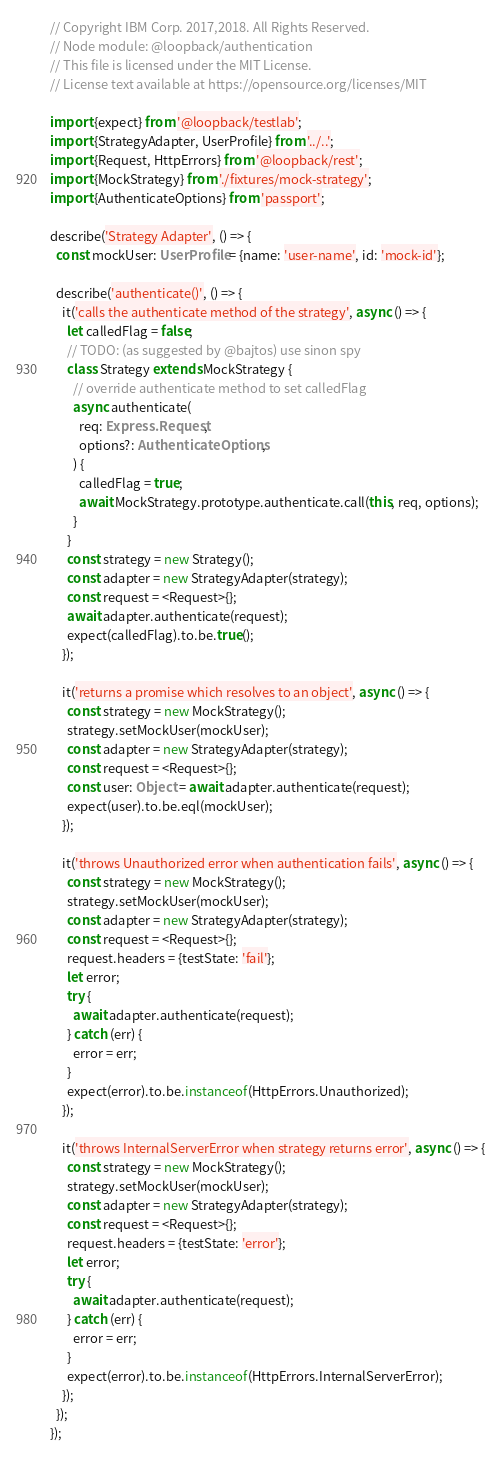<code> <loc_0><loc_0><loc_500><loc_500><_TypeScript_>// Copyright IBM Corp. 2017,2018. All Rights Reserved.
// Node module: @loopback/authentication
// This file is licensed under the MIT License.
// License text available at https://opensource.org/licenses/MIT

import {expect} from '@loopback/testlab';
import {StrategyAdapter, UserProfile} from '../..';
import {Request, HttpErrors} from '@loopback/rest';
import {MockStrategy} from './fixtures/mock-strategy';
import {AuthenticateOptions} from 'passport';

describe('Strategy Adapter', () => {
  const mockUser: UserProfile = {name: 'user-name', id: 'mock-id'};

  describe('authenticate()', () => {
    it('calls the authenticate method of the strategy', async () => {
      let calledFlag = false;
      // TODO: (as suggested by @bajtos) use sinon spy
      class Strategy extends MockStrategy {
        // override authenticate method to set calledFlag
        async authenticate(
          req: Express.Request,
          options?: AuthenticateOptions,
        ) {
          calledFlag = true;
          await MockStrategy.prototype.authenticate.call(this, req, options);
        }
      }
      const strategy = new Strategy();
      const adapter = new StrategyAdapter(strategy);
      const request = <Request>{};
      await adapter.authenticate(request);
      expect(calledFlag).to.be.true();
    });

    it('returns a promise which resolves to an object', async () => {
      const strategy = new MockStrategy();
      strategy.setMockUser(mockUser);
      const adapter = new StrategyAdapter(strategy);
      const request = <Request>{};
      const user: Object = await adapter.authenticate(request);
      expect(user).to.be.eql(mockUser);
    });

    it('throws Unauthorized error when authentication fails', async () => {
      const strategy = new MockStrategy();
      strategy.setMockUser(mockUser);
      const adapter = new StrategyAdapter(strategy);
      const request = <Request>{};
      request.headers = {testState: 'fail'};
      let error;
      try {
        await adapter.authenticate(request);
      } catch (err) {
        error = err;
      }
      expect(error).to.be.instanceof(HttpErrors.Unauthorized);
    });

    it('throws InternalServerError when strategy returns error', async () => {
      const strategy = new MockStrategy();
      strategy.setMockUser(mockUser);
      const adapter = new StrategyAdapter(strategy);
      const request = <Request>{};
      request.headers = {testState: 'error'};
      let error;
      try {
        await adapter.authenticate(request);
      } catch (err) {
        error = err;
      }
      expect(error).to.be.instanceof(HttpErrors.InternalServerError);
    });
  });
});
</code> 